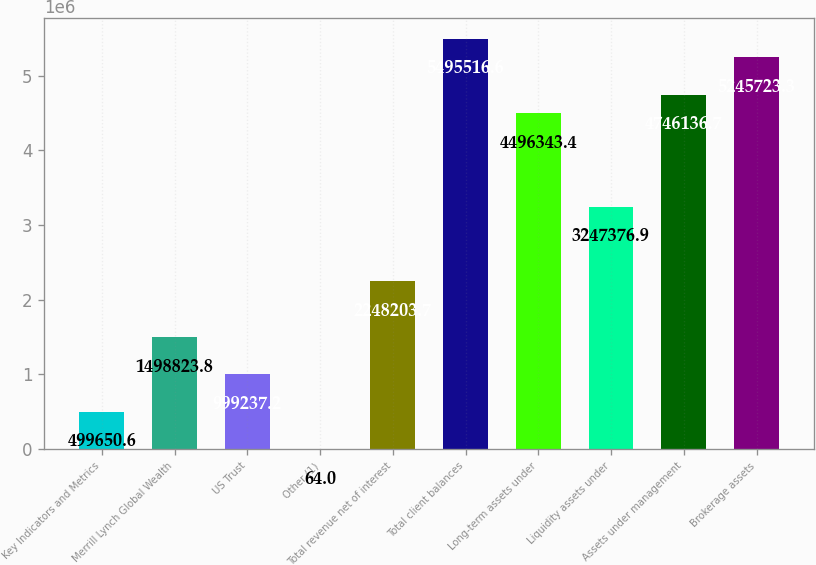<chart> <loc_0><loc_0><loc_500><loc_500><bar_chart><fcel>Key Indicators and Metrics<fcel>Merrill Lynch Global Wealth<fcel>US Trust<fcel>Other (1)<fcel>Total revenue net of interest<fcel>Total client balances<fcel>Long-term assets under<fcel>Liquidity assets under<fcel>Assets under management<fcel>Brokerage assets<nl><fcel>499651<fcel>1.49882e+06<fcel>999237<fcel>64<fcel>2.2482e+06<fcel>5.49552e+06<fcel>4.49634e+06<fcel>3.24738e+06<fcel>4.74614e+06<fcel>5.24572e+06<nl></chart> 